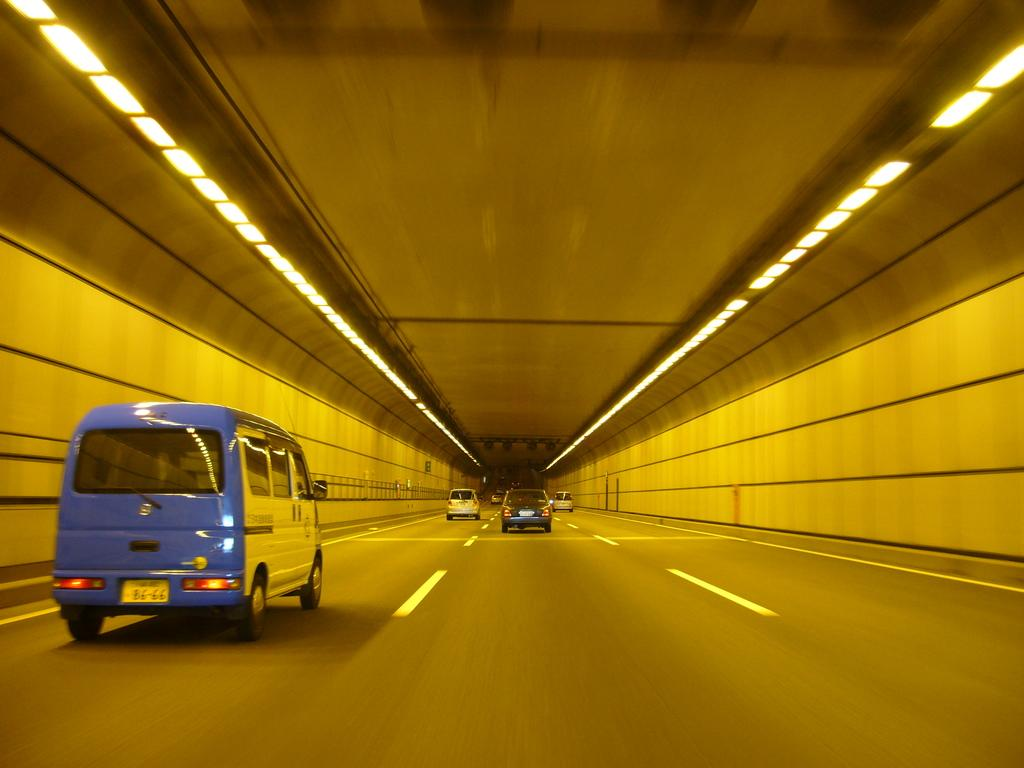What can be seen on the road in the image? There are vehicles on the road in the image. What else is visible in the image besides the vehicles? There are lights and a wall visible in the image. How many cherries are hanging from the wall in the image? There are no cherries visible in the image; only vehicles, lights, and a wall can be seen. 